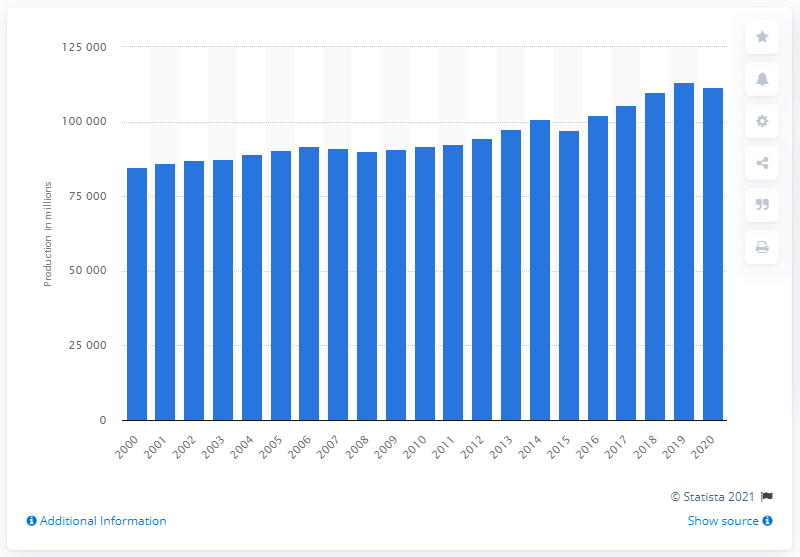Specify some key components in this picture. In 2020, a total of 111,573.3 million eggs were produced in the United States. 